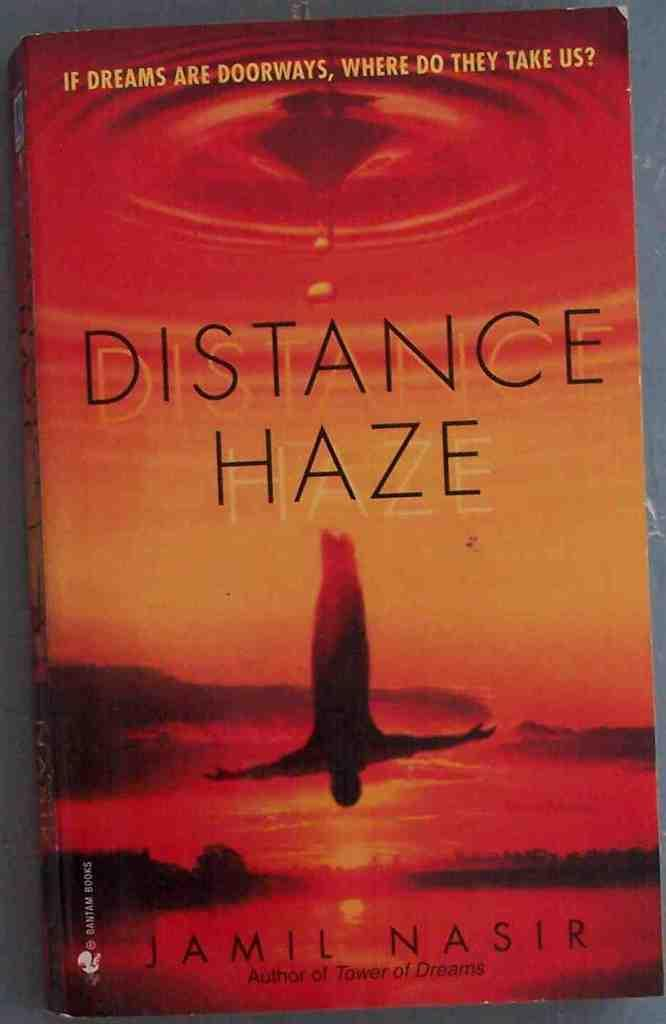<image>
Create a compact narrative representing the image presented. A book by Jamil Nasir with an orange/red cover. 